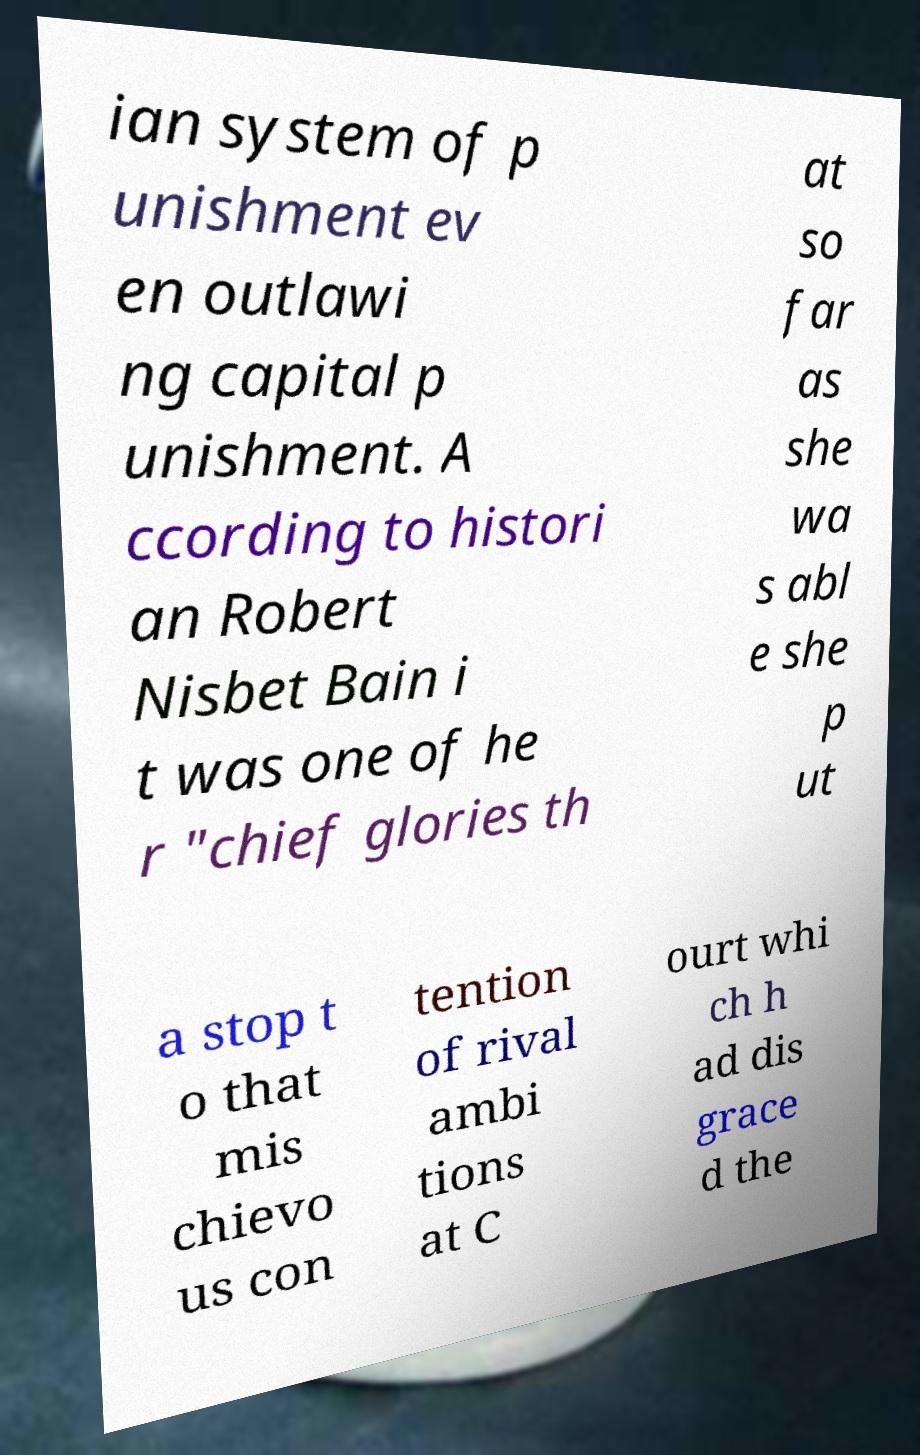Could you assist in decoding the text presented in this image and type it out clearly? ian system of p unishment ev en outlawi ng capital p unishment. A ccording to histori an Robert Nisbet Bain i t was one of he r "chief glories th at so far as she wa s abl e she p ut a stop t o that mis chievo us con tention of rival ambi tions at C ourt whi ch h ad dis grace d the 